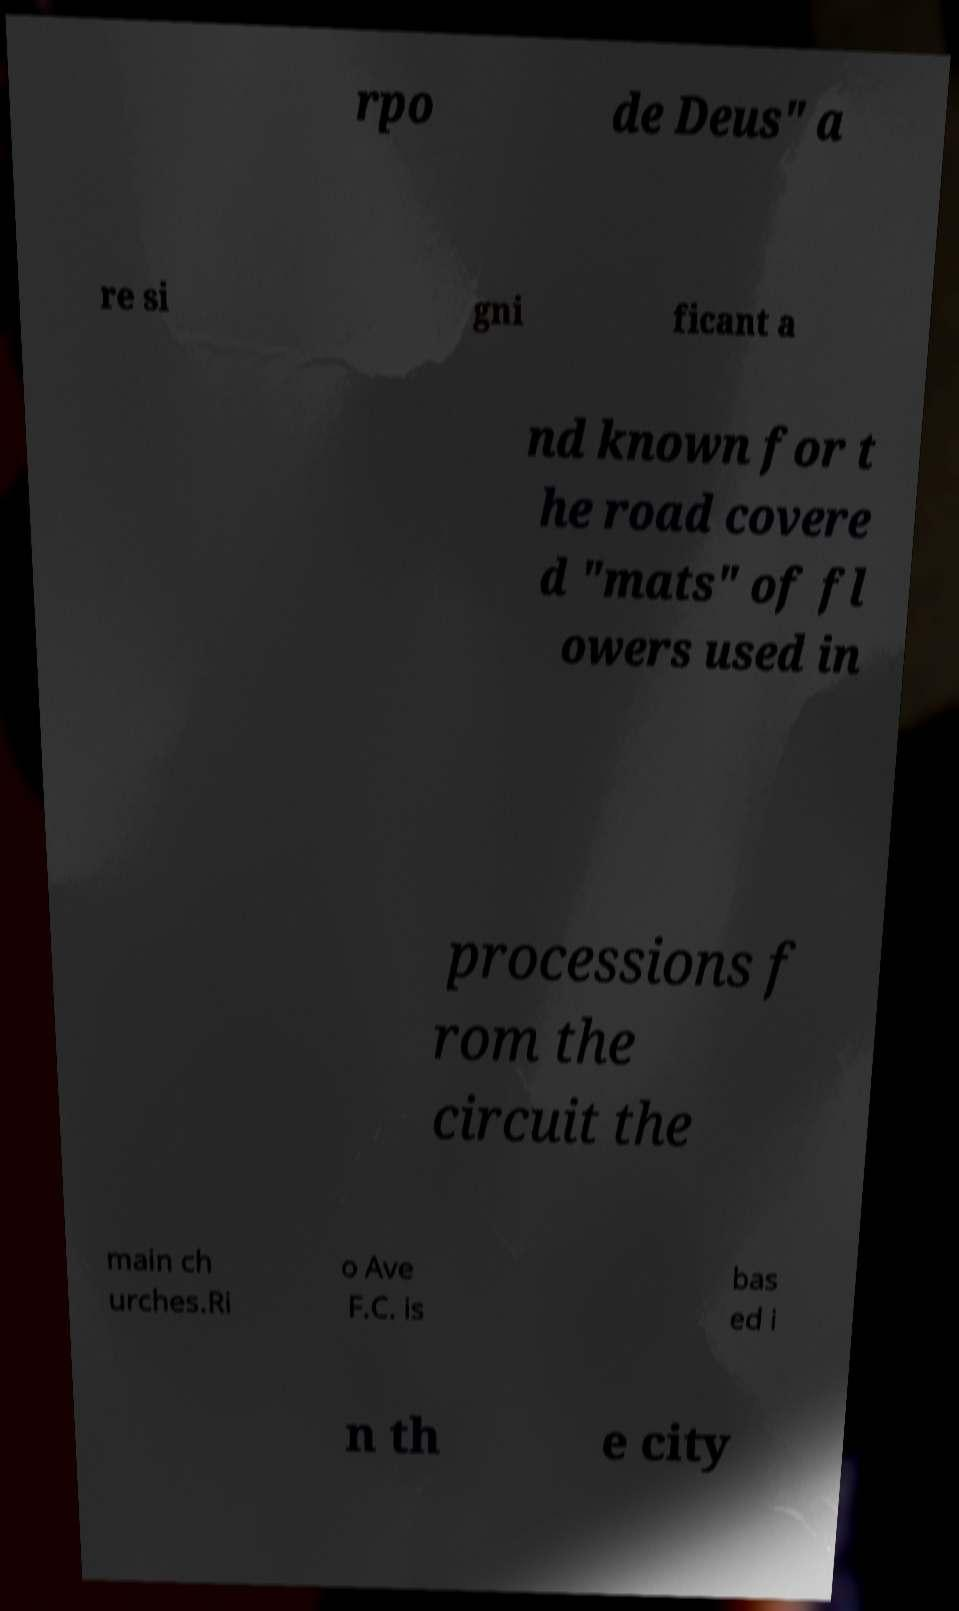Can you read and provide the text displayed in the image?This photo seems to have some interesting text. Can you extract and type it out for me? rpo de Deus" a re si gni ficant a nd known for t he road covere d "mats" of fl owers used in processions f rom the circuit the main ch urches.Ri o Ave F.C. is bas ed i n th e city 